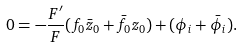Convert formula to latex. <formula><loc_0><loc_0><loc_500><loc_500>0 = - \frac { F ^ { \prime } } { F } ( f _ { 0 } \bar { z } _ { 0 } + \bar { f } _ { 0 } z _ { 0 } ) + ( \phi _ { i } + \bar { \phi } _ { i } ) .</formula> 